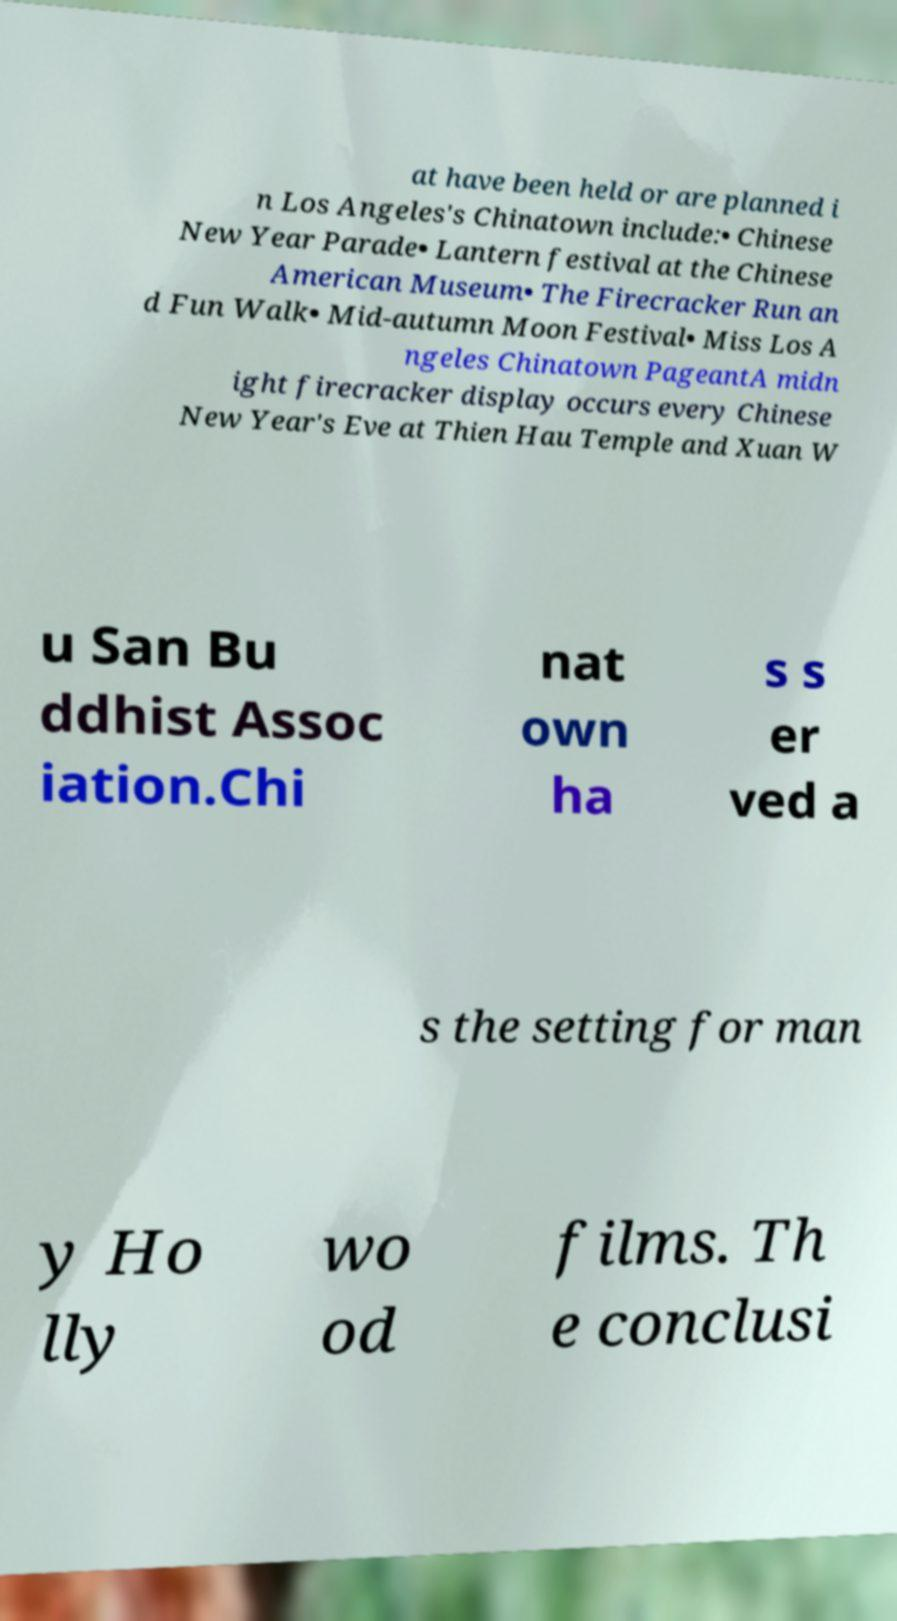Could you extract and type out the text from this image? at have been held or are planned i n Los Angeles's Chinatown include:• Chinese New Year Parade• Lantern festival at the Chinese American Museum• The Firecracker Run an d Fun Walk• Mid-autumn Moon Festival• Miss Los A ngeles Chinatown PageantA midn ight firecracker display occurs every Chinese New Year's Eve at Thien Hau Temple and Xuan W u San Bu ddhist Assoc iation.Chi nat own ha s s er ved a s the setting for man y Ho lly wo od films. Th e conclusi 